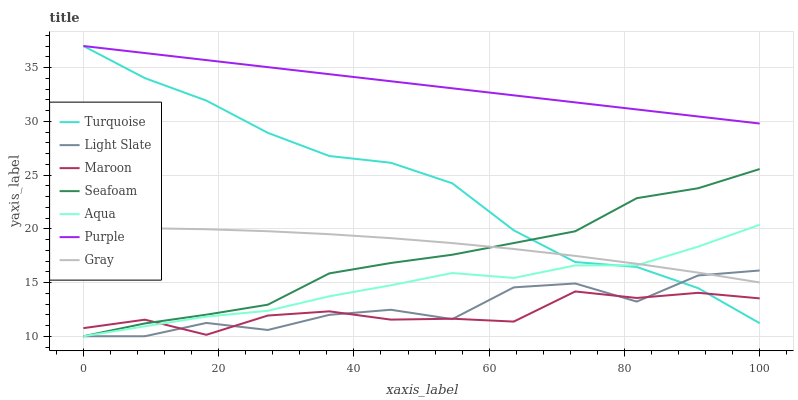Does Maroon have the minimum area under the curve?
Answer yes or no. Yes. Does Purple have the maximum area under the curve?
Answer yes or no. Yes. Does Turquoise have the minimum area under the curve?
Answer yes or no. No. Does Turquoise have the maximum area under the curve?
Answer yes or no. No. Is Purple the smoothest?
Answer yes or no. Yes. Is Light Slate the roughest?
Answer yes or no. Yes. Is Turquoise the smoothest?
Answer yes or no. No. Is Turquoise the roughest?
Answer yes or no. No. Does Light Slate have the lowest value?
Answer yes or no. Yes. Does Turquoise have the lowest value?
Answer yes or no. No. Does Purple have the highest value?
Answer yes or no. Yes. Does Light Slate have the highest value?
Answer yes or no. No. Is Light Slate less than Purple?
Answer yes or no. Yes. Is Purple greater than Gray?
Answer yes or no. Yes. Does Gray intersect Turquoise?
Answer yes or no. Yes. Is Gray less than Turquoise?
Answer yes or no. No. Is Gray greater than Turquoise?
Answer yes or no. No. Does Light Slate intersect Purple?
Answer yes or no. No. 